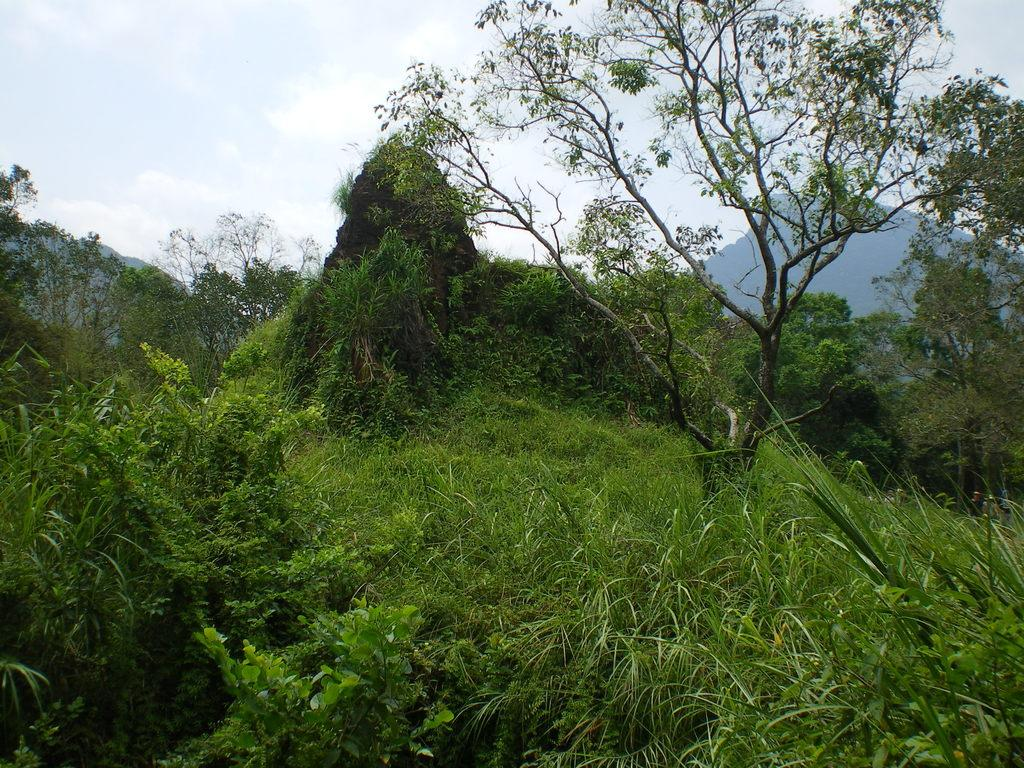What type of vegetation can be seen in the image? There are trees and plants in the image. What can be seen in the background of the image? There are hills and the sky visible in the background of the image. What is the condition of the sky in the image? Clouds are present in the sky in the image. How many feathers can be seen in the image? There are no feathers present in the image. Is there any quicksand visible in the image? There is no quicksand present in the image. 